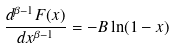Convert formula to latex. <formula><loc_0><loc_0><loc_500><loc_500>\frac { d ^ { \beta - 1 } F ( x ) } { d x ^ { \beta - 1 } } = - B \ln ( 1 - x )</formula> 